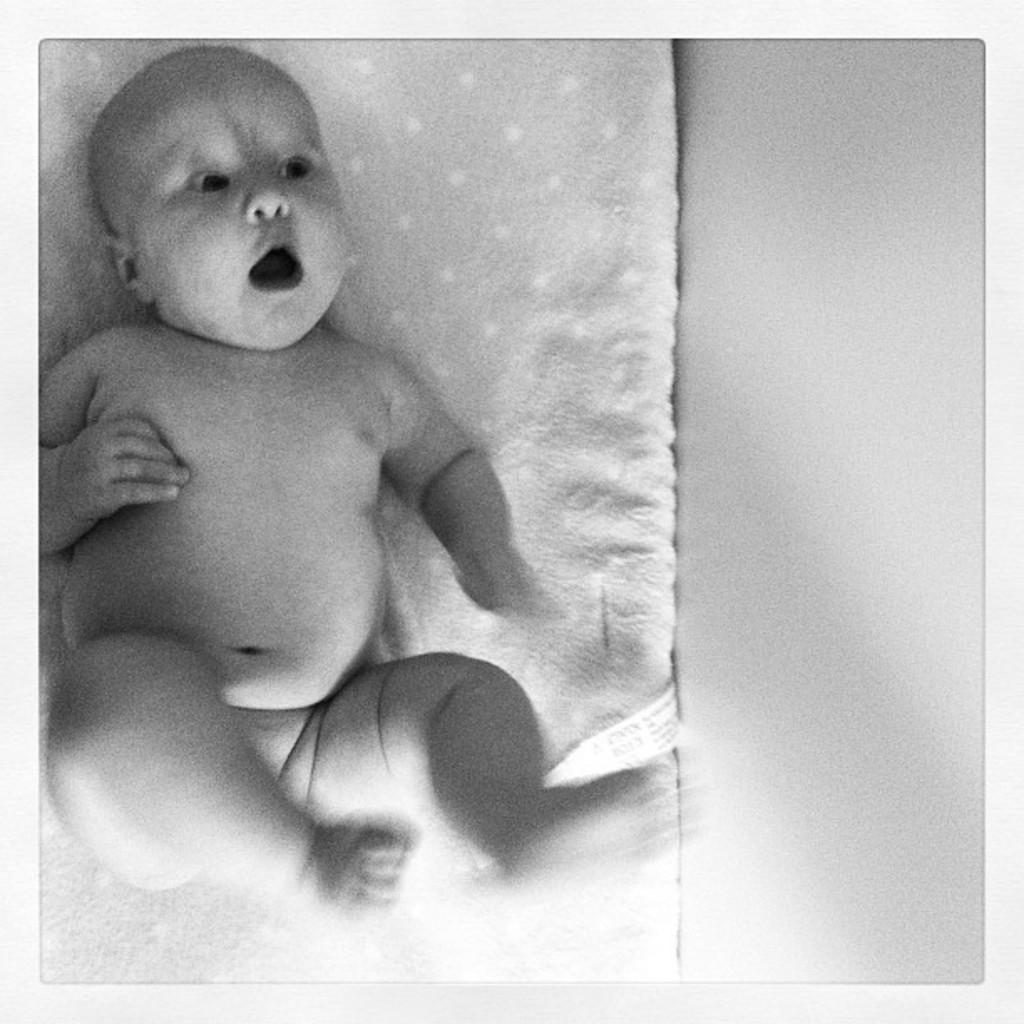What is the main subject of the image? There is a baby in the image. What is the baby lying on? The baby is lying on a cloth. What can be seen on the right side of the image? There is a wall visible to the right side of the image. Is the baby driving a car in the image? No, the baby is not driving a car in the image; they are lying on a cloth. What type of letters can be seen on the wall in the image? There are no letters visible on the wall in the image. 